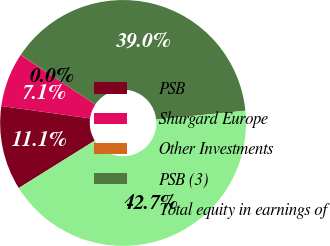Convert chart. <chart><loc_0><loc_0><loc_500><loc_500><pie_chart><fcel>PSB<fcel>Shurgard Europe<fcel>Other Investments<fcel>PSB (3)<fcel>Total equity in earnings of<nl><fcel>11.08%<fcel>7.14%<fcel>0.02%<fcel>39.05%<fcel>42.71%<nl></chart> 